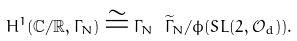Convert formula to latex. <formula><loc_0><loc_0><loc_500><loc_500>H ^ { 1 } ( \mathbb { C } / \mathbb { R } , \Gamma _ { N } ) \cong \Gamma _ { N } \ \widetilde { \Gamma } _ { N } / \phi ( S L ( 2 , \mathcal { O } _ { d } ) ) .</formula> 